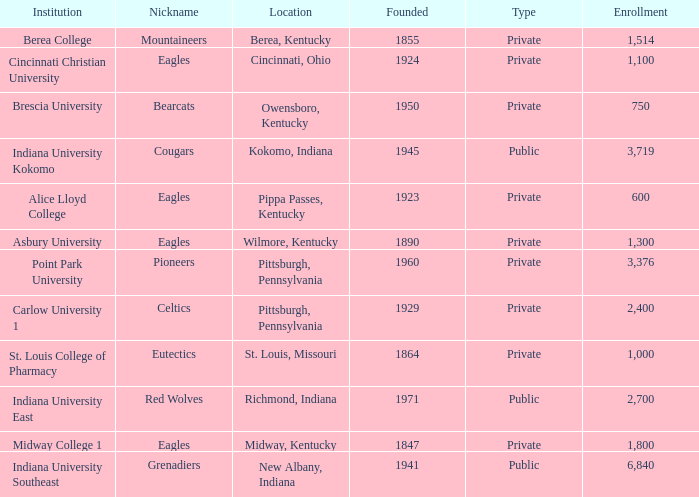Which public college has a nickname of The Grenadiers? Indiana University Southeast. 